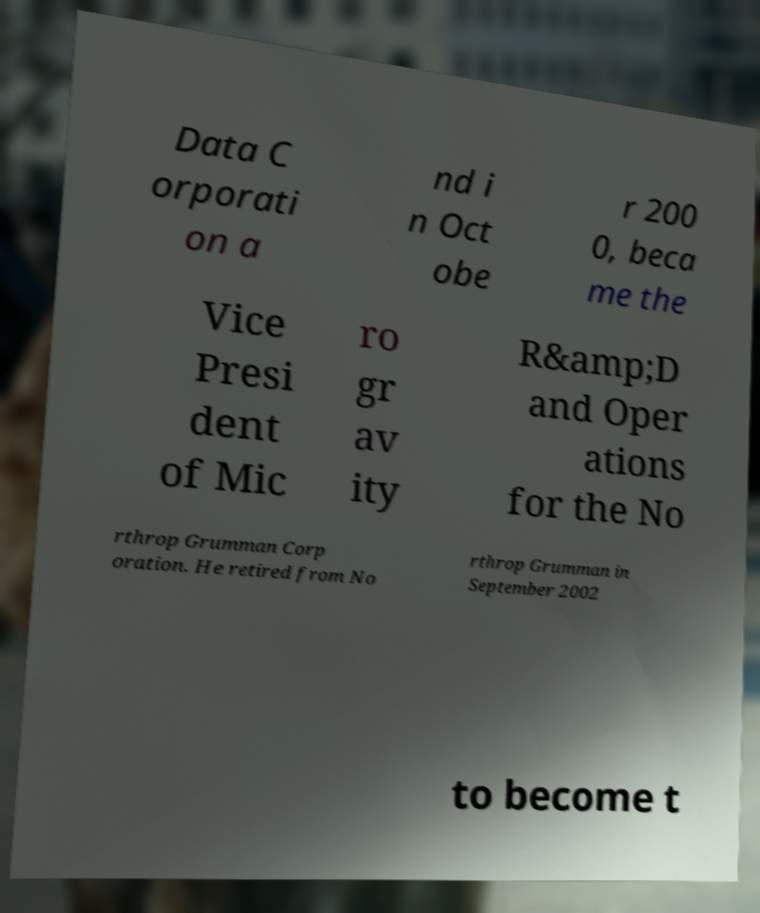For documentation purposes, I need the text within this image transcribed. Could you provide that? Data C orporati on a nd i n Oct obe r 200 0, beca me the Vice Presi dent of Mic ro gr av ity R&amp;D and Oper ations for the No rthrop Grumman Corp oration. He retired from No rthrop Grumman in September 2002 to become t 